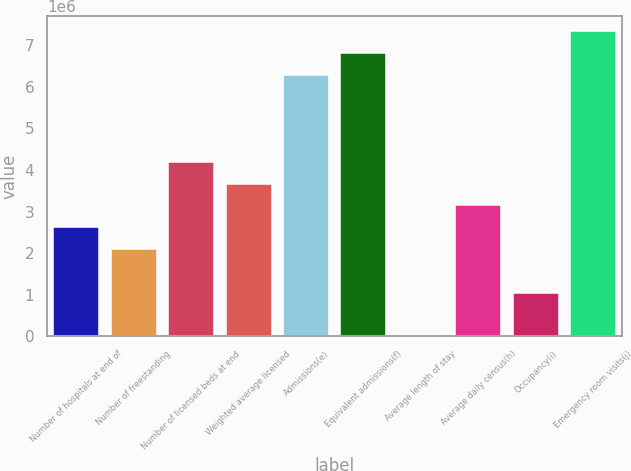<chart> <loc_0><loc_0><loc_500><loc_500><bar_chart><fcel>Number of hospitals at end of<fcel>Number of freestanding<fcel>Number of licensed beds at end<fcel>Weighted average licensed<fcel>Admissions(e)<fcel>Equivalent admissions(f)<fcel>Average length of stay<fcel>Average daily census(h)<fcel>Occupancy(i)<fcel>Emergency room visits(j)<nl><fcel>2.6232e+06<fcel>2.09856e+06<fcel>4.19712e+06<fcel>3.67248e+06<fcel>6.29568e+06<fcel>6.82032e+06<fcel>4.9<fcel>3.14784e+06<fcel>1.04928e+06<fcel>7.34496e+06<nl></chart> 